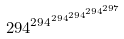<formula> <loc_0><loc_0><loc_500><loc_500>2 9 4 ^ { 2 9 4 ^ { 2 9 4 ^ { 2 9 4 ^ { 2 9 4 ^ { 2 9 7 } } } } }</formula> 